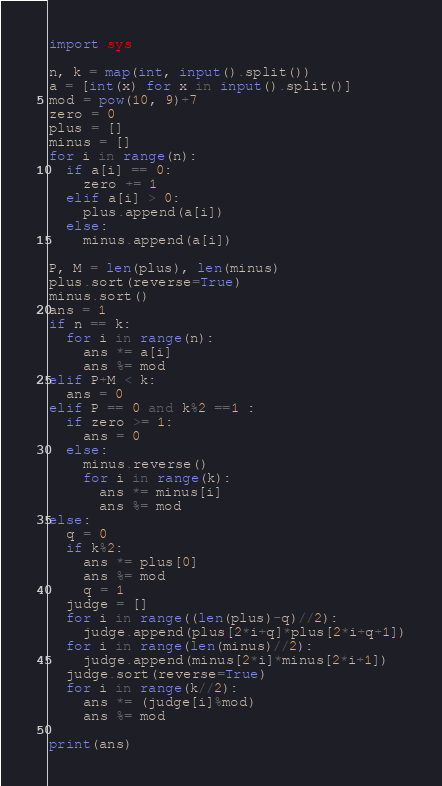Convert code to text. <code><loc_0><loc_0><loc_500><loc_500><_Python_>import sys
 
n, k = map(int, input().split())
a = [int(x) for x in input().split()]
mod = pow(10, 9)+7
zero = 0
plus = []
minus = []
for i in range(n):
  if a[i] == 0:
    zero += 1
  elif a[i] > 0:
    plus.append(a[i])
  else:
    minus.append(a[i])
 
P, M = len(plus), len(minus)
plus.sort(reverse=True)
minus.sort()
ans = 1
if n == k:
  for i in range(n):
    ans *= a[i]
    ans %= mod
elif P+M < k:
  ans = 0
elif P == 0 and k%2 ==1 :
  if zero >= 1:
    ans = 0
  else:
    minus.reverse()
    for i in range(k):
      ans *= minus[i]
      ans %= mod
else:
  q = 0
  if k%2:
    ans *= plus[0]
    ans %= mod
    q = 1
  judge = []
  for i in range((len(plus)-q)//2):
    judge.append(plus[2*i+q]*plus[2*i+q+1])
  for i in range(len(minus)//2):
    judge.append(minus[2*i]*minus[2*i+1])
  judge.sort(reverse=True)
  for i in range(k//2):
    ans *= (judge[i]%mod)
    ans %= mod
 
print(ans)</code> 